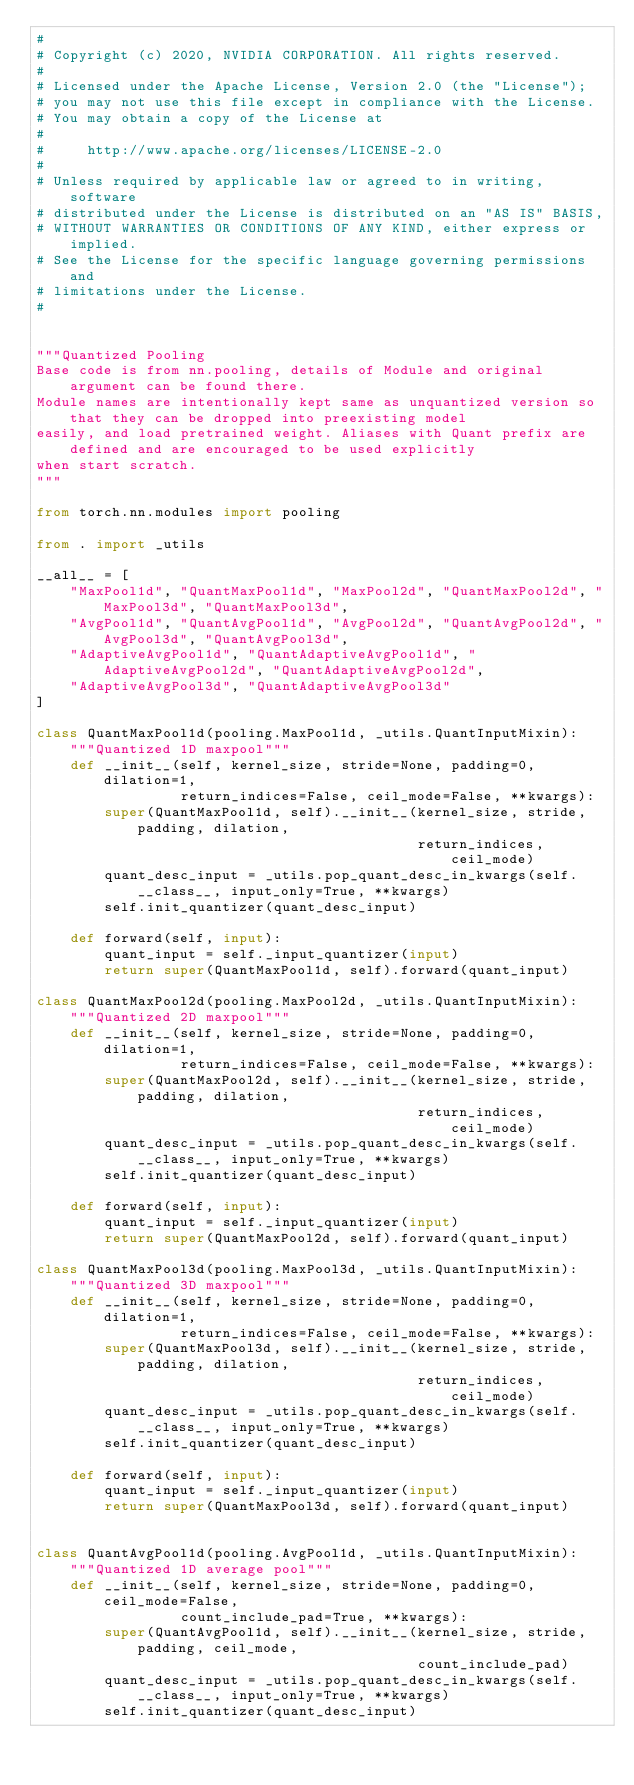Convert code to text. <code><loc_0><loc_0><loc_500><loc_500><_Python_>#
# Copyright (c) 2020, NVIDIA CORPORATION. All rights reserved.
#
# Licensed under the Apache License, Version 2.0 (the "License");
# you may not use this file except in compliance with the License.
# You may obtain a copy of the License at
#
#     http://www.apache.org/licenses/LICENSE-2.0
#
# Unless required by applicable law or agreed to in writing, software
# distributed under the License is distributed on an "AS IS" BASIS,
# WITHOUT WARRANTIES OR CONDITIONS OF ANY KIND, either express or implied.
# See the License for the specific language governing permissions and
# limitations under the License.
#


"""Quantized Pooling
Base code is from nn.pooling, details of Module and original argument can be found there.
Module names are intentionally kept same as unquantized version so that they can be dropped into preexisting model
easily, and load pretrained weight. Aliases with Quant prefix are defined and are encouraged to be used explicitly
when start scratch.
"""

from torch.nn.modules import pooling

from . import _utils

__all__ = [
    "MaxPool1d", "QuantMaxPool1d", "MaxPool2d", "QuantMaxPool2d", "MaxPool3d", "QuantMaxPool3d",
    "AvgPool1d", "QuantAvgPool1d", "AvgPool2d", "QuantAvgPool2d", "AvgPool3d", "QuantAvgPool3d",
    "AdaptiveAvgPool1d", "QuantAdaptiveAvgPool1d", "AdaptiveAvgPool2d", "QuantAdaptiveAvgPool2d",
    "AdaptiveAvgPool3d", "QuantAdaptiveAvgPool3d"
]

class QuantMaxPool1d(pooling.MaxPool1d, _utils.QuantInputMixin):
    """Quantized 1D maxpool"""
    def __init__(self, kernel_size, stride=None, padding=0, dilation=1,
                 return_indices=False, ceil_mode=False, **kwargs):
        super(QuantMaxPool1d, self).__init__(kernel_size, stride, padding, dilation,
                                             return_indices, ceil_mode)
        quant_desc_input = _utils.pop_quant_desc_in_kwargs(self.__class__, input_only=True, **kwargs)
        self.init_quantizer(quant_desc_input)

    def forward(self, input):
        quant_input = self._input_quantizer(input)
        return super(QuantMaxPool1d, self).forward(quant_input)

class QuantMaxPool2d(pooling.MaxPool2d, _utils.QuantInputMixin):
    """Quantized 2D maxpool"""
    def __init__(self, kernel_size, stride=None, padding=0, dilation=1,
                 return_indices=False, ceil_mode=False, **kwargs):
        super(QuantMaxPool2d, self).__init__(kernel_size, stride, padding, dilation,
                                             return_indices, ceil_mode)
        quant_desc_input = _utils.pop_quant_desc_in_kwargs(self.__class__, input_only=True, **kwargs)
        self.init_quantizer(quant_desc_input)

    def forward(self, input):
        quant_input = self._input_quantizer(input)
        return super(QuantMaxPool2d, self).forward(quant_input)

class QuantMaxPool3d(pooling.MaxPool3d, _utils.QuantInputMixin):
    """Quantized 3D maxpool"""
    def __init__(self, kernel_size, stride=None, padding=0, dilation=1,
                 return_indices=False, ceil_mode=False, **kwargs):
        super(QuantMaxPool3d, self).__init__(kernel_size, stride, padding, dilation,
                                             return_indices, ceil_mode)
        quant_desc_input = _utils.pop_quant_desc_in_kwargs(self.__class__, input_only=True, **kwargs)
        self.init_quantizer(quant_desc_input)

    def forward(self, input):
        quant_input = self._input_quantizer(input)
        return super(QuantMaxPool3d, self).forward(quant_input)


class QuantAvgPool1d(pooling.AvgPool1d, _utils.QuantInputMixin):
    """Quantized 1D average pool"""
    def __init__(self, kernel_size, stride=None, padding=0, ceil_mode=False,
                 count_include_pad=True, **kwargs):
        super(QuantAvgPool1d, self).__init__(kernel_size, stride, padding, ceil_mode,
                                             count_include_pad)
        quant_desc_input = _utils.pop_quant_desc_in_kwargs(self.__class__, input_only=True, **kwargs)
        self.init_quantizer(quant_desc_input)
</code> 